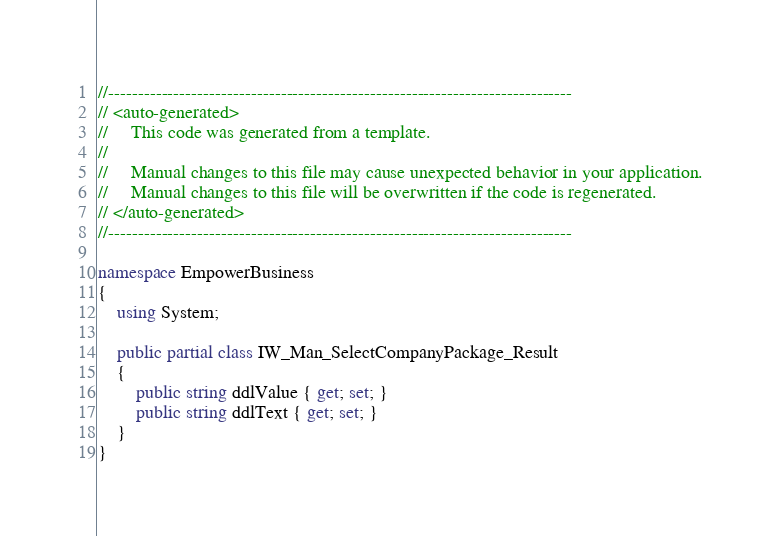Convert code to text. <code><loc_0><loc_0><loc_500><loc_500><_C#_>//------------------------------------------------------------------------------
// <auto-generated>
//     This code was generated from a template.
//
//     Manual changes to this file may cause unexpected behavior in your application.
//     Manual changes to this file will be overwritten if the code is regenerated.
// </auto-generated>
//------------------------------------------------------------------------------

namespace EmpowerBusiness
{
    using System;
    
    public partial class IW_Man_SelectCompanyPackage_Result
    {
        public string ddlValue { get; set; }
        public string ddlText { get; set; }
    }
}
</code> 